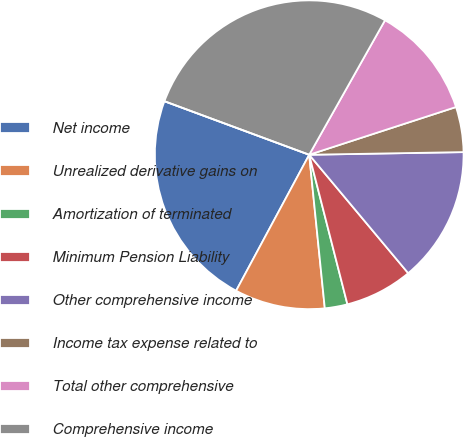<chart> <loc_0><loc_0><loc_500><loc_500><pie_chart><fcel>Net income<fcel>Unrealized derivative gains on<fcel>Amortization of terminated<fcel>Minimum Pension Liability<fcel>Other comprehensive income<fcel>Income tax expense related to<fcel>Total other comprehensive<fcel>Comprehensive income<fcel>Less Comprehensive income<nl><fcel>22.79%<fcel>9.46%<fcel>2.37%<fcel>7.1%<fcel>14.19%<fcel>4.73%<fcel>11.83%<fcel>27.53%<fcel>0.0%<nl></chart> 